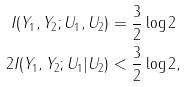<formula> <loc_0><loc_0><loc_500><loc_500>I ( Y _ { 1 } , Y _ { 2 } ; U _ { 1 } , U _ { 2 } ) & = \frac { 3 } { 2 } \log 2 \\ 2 I ( Y _ { 1 } , Y _ { 2 } ; U _ { 1 } | U _ { 2 } ) & < \frac { 3 } { 2 } \log 2 ,</formula> 